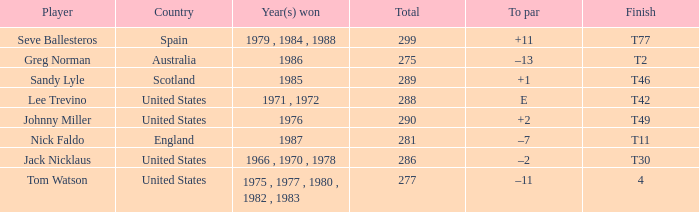Would you mind parsing the complete table? {'header': ['Player', 'Country', 'Year(s) won', 'Total', 'To par', 'Finish'], 'rows': [['Seve Ballesteros', 'Spain', '1979 , 1984 , 1988', '299', '+11', 'T77'], ['Greg Norman', 'Australia', '1986', '275', '–13', 'T2'], ['Sandy Lyle', 'Scotland', '1985', '289', '+1', 'T46'], ['Lee Trevino', 'United States', '1971 , 1972', '288', 'E', 'T42'], ['Johnny Miller', 'United States', '1976', '290', '+2', 'T49'], ['Nick Faldo', 'England', '1987', '281', '–7', 'T11'], ['Jack Nicklaus', 'United States', '1966 , 1970 , 1978', '286', '–2', 'T30'], ['Tom Watson', 'United States', '1975 , 1977 , 1980 , 1982 , 1983', '277', '–11', '4']]} What's england's to par? –7. 